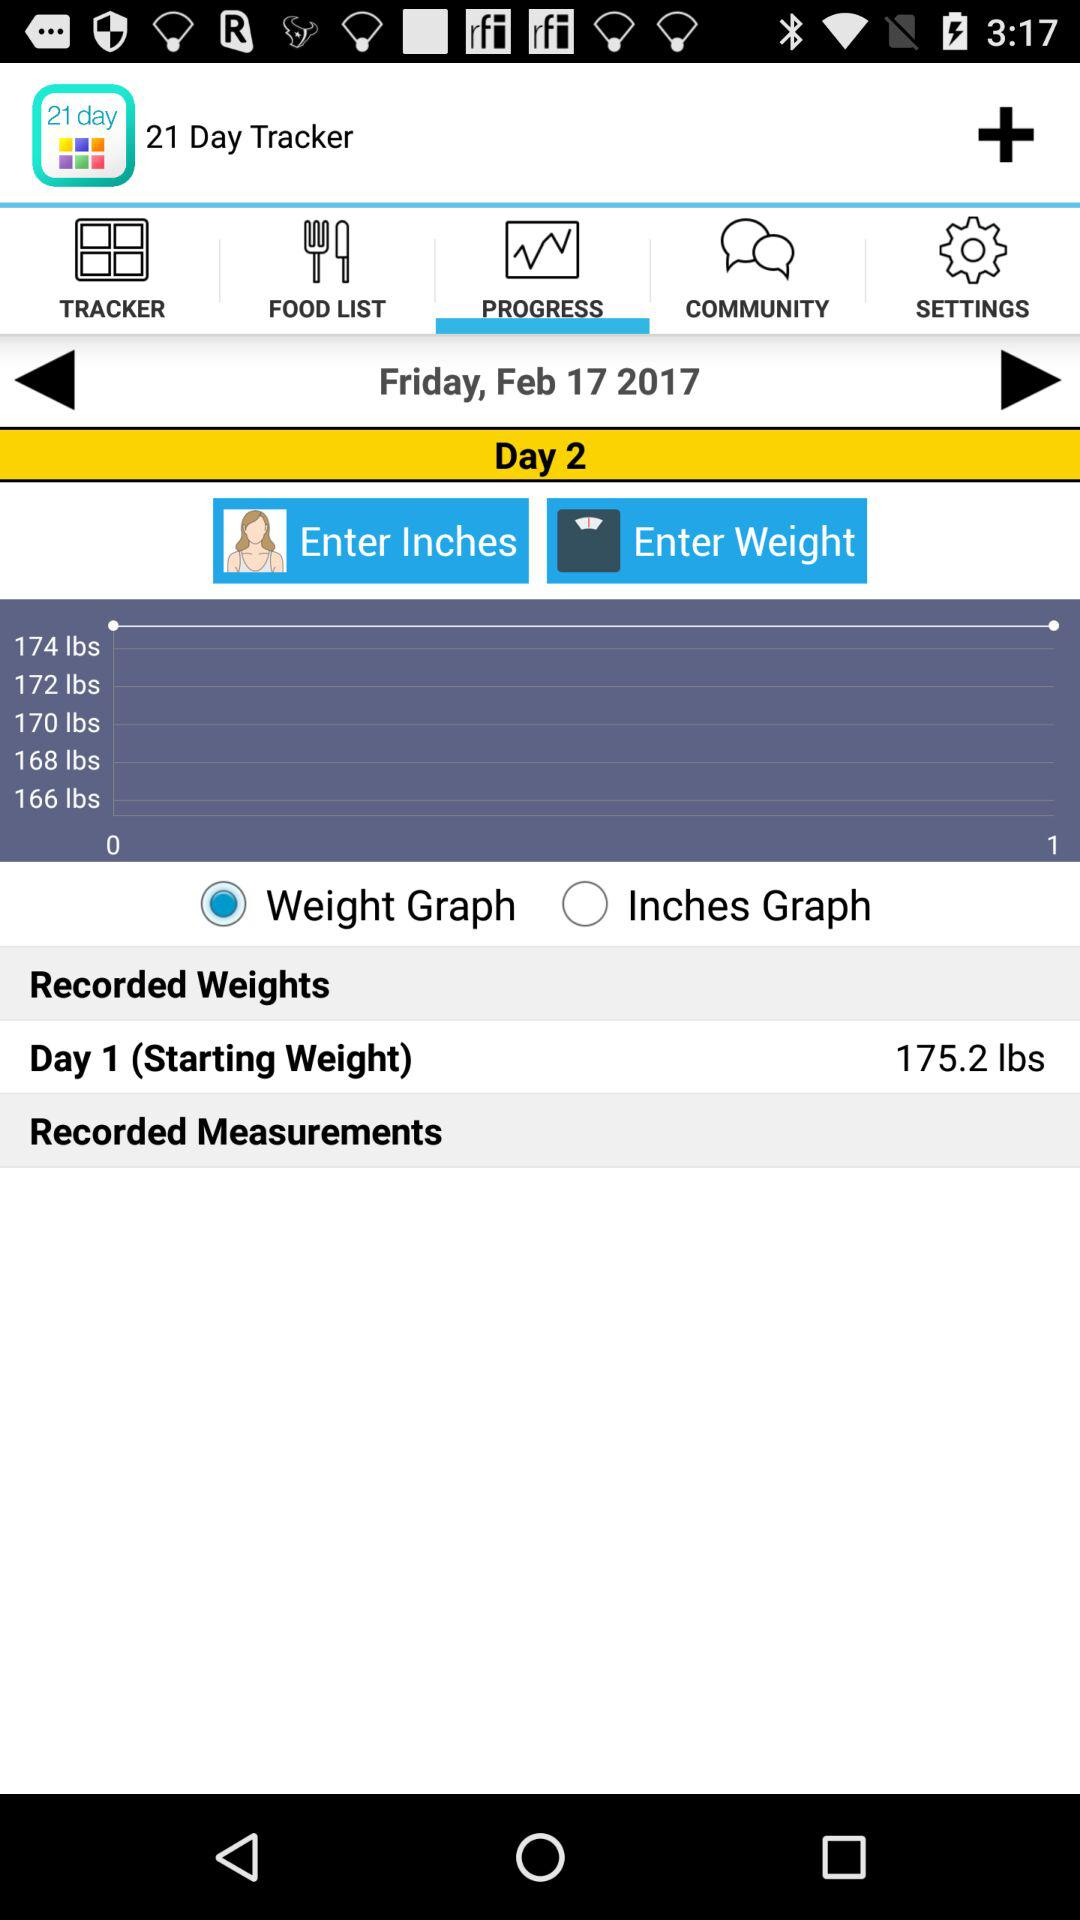What is the date? The date is Friday, February 17, 2017. 